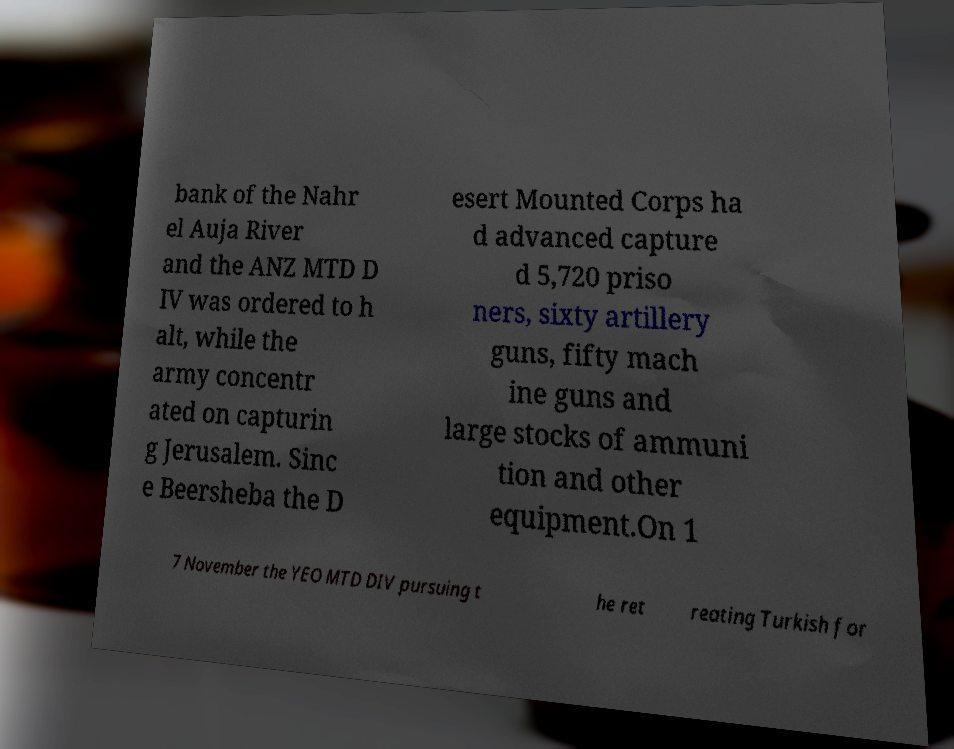Could you extract and type out the text from this image? bank of the Nahr el Auja River and the ANZ MTD D IV was ordered to h alt, while the army concentr ated on capturin g Jerusalem. Sinc e Beersheba the D esert Mounted Corps ha d advanced capture d 5,720 priso ners, sixty artillery guns, fifty mach ine guns and large stocks of ammuni tion and other equipment.On 1 7 November the YEO MTD DIV pursuing t he ret reating Turkish for 